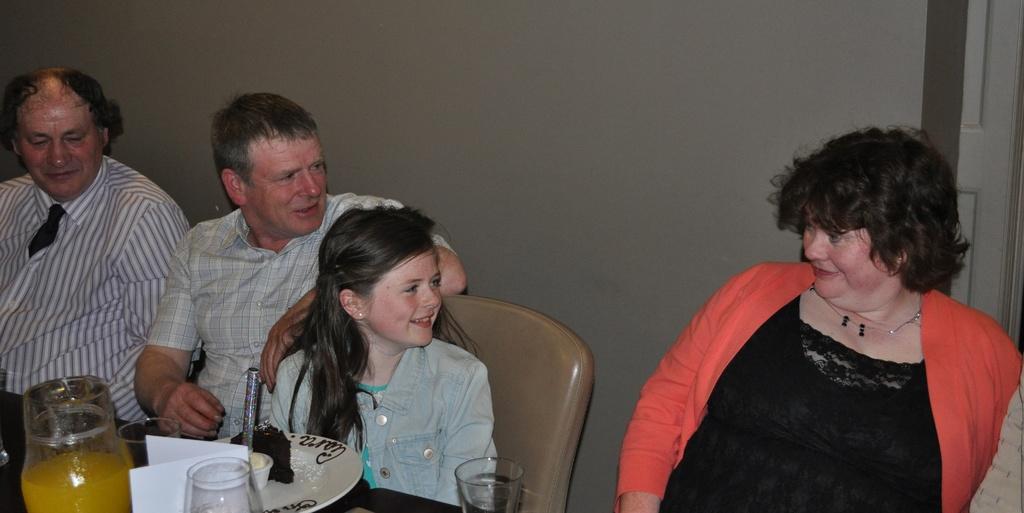Describe this image in one or two sentences. In this image we can see persons sitting at the table. On the table there is a jar, glasses, plate, cake and candle. In the background there is a wall and door. 